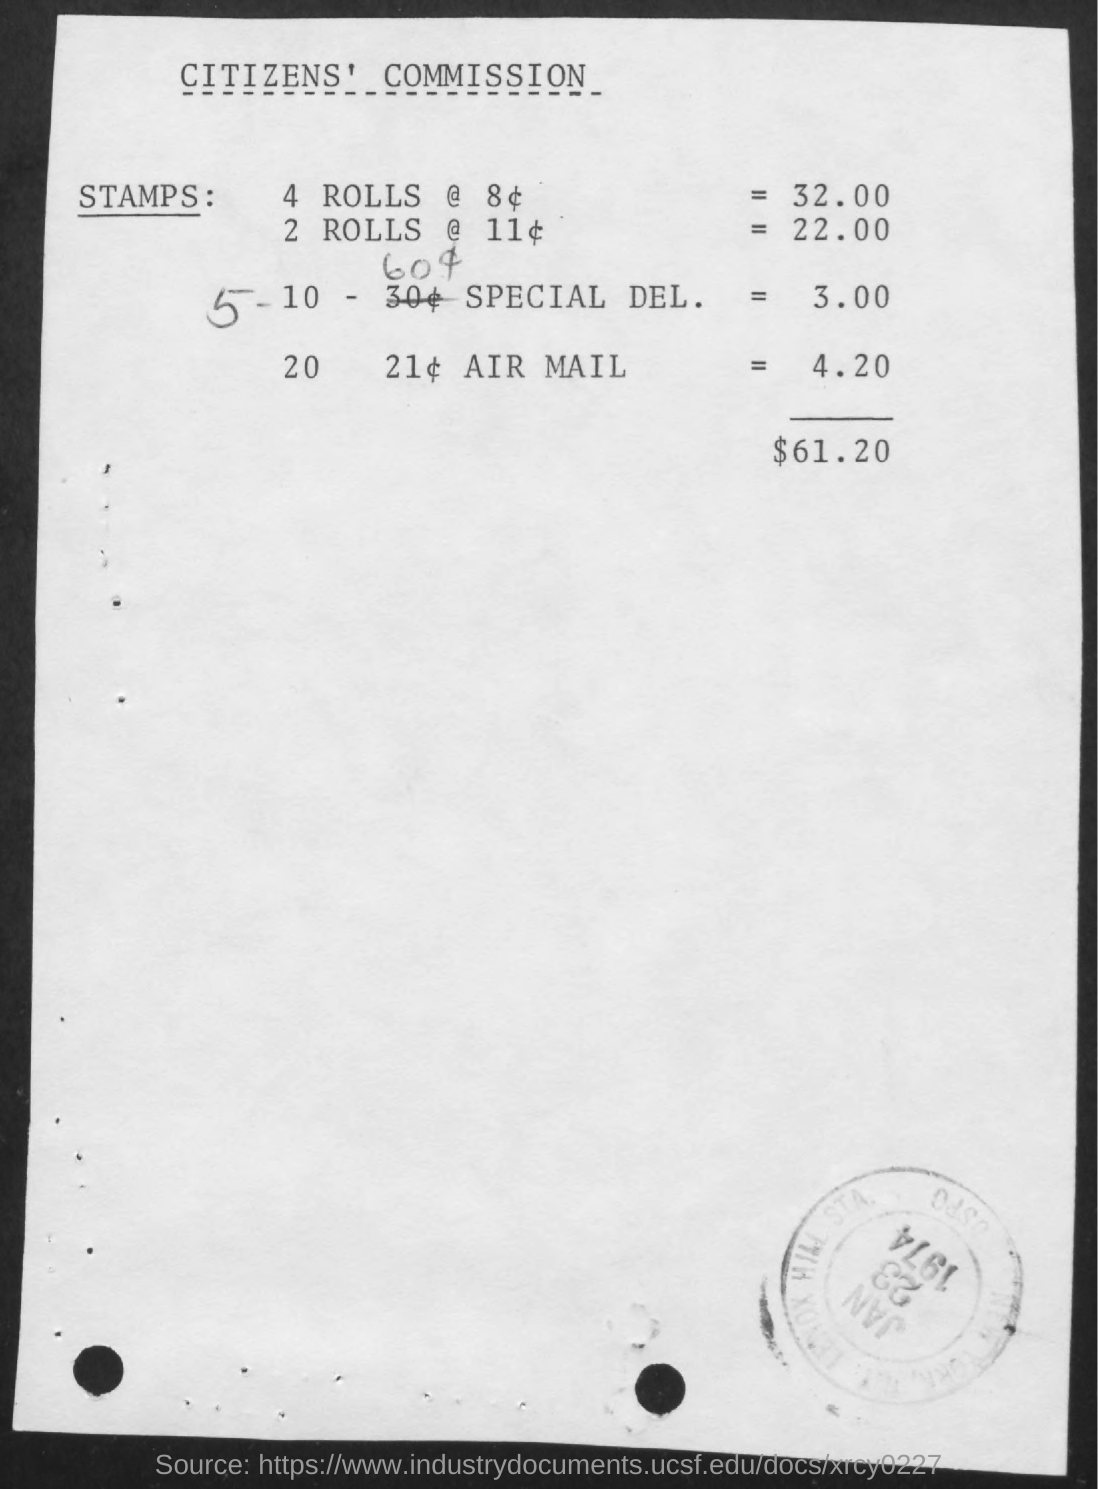Draw attention to some important aspects in this diagram. The title of the document is the Citizens' Commission. The total of the transaction is $61.20. 